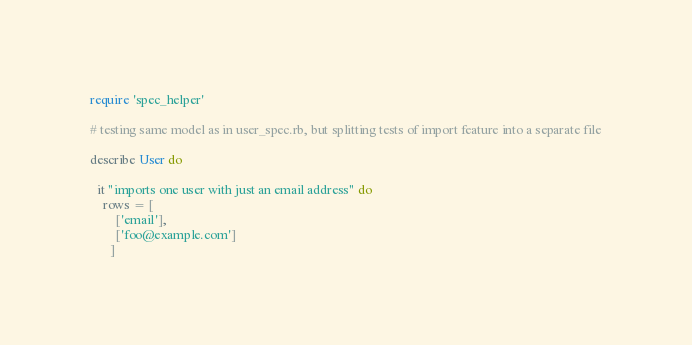<code> <loc_0><loc_0><loc_500><loc_500><_Ruby_>require 'spec_helper'

# testing same model as in user_spec.rb, but splitting tests of import feature into a separate file

describe User do

  it "imports one user with just an email address" do
    rows = [
        ['email'],
        ['foo@example.com']
      ]</code> 